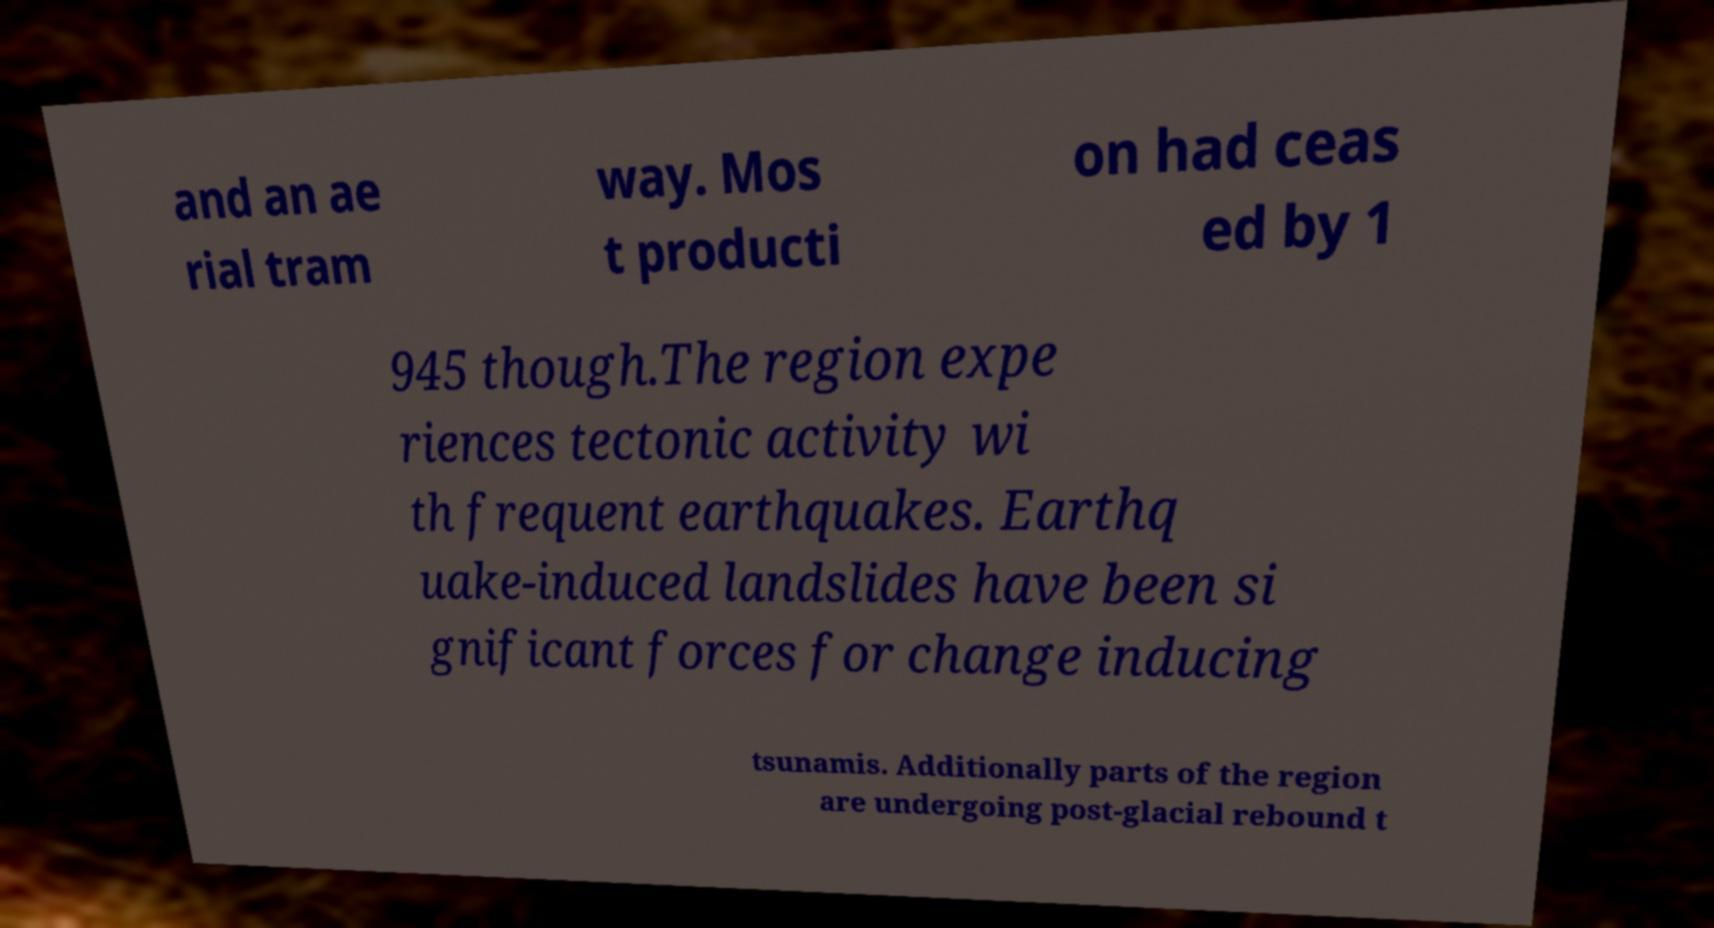Could you extract and type out the text from this image? and an ae rial tram way. Mos t producti on had ceas ed by 1 945 though.The region expe riences tectonic activity wi th frequent earthquakes. Earthq uake-induced landslides have been si gnificant forces for change inducing tsunamis. Additionally parts of the region are undergoing post-glacial rebound t 